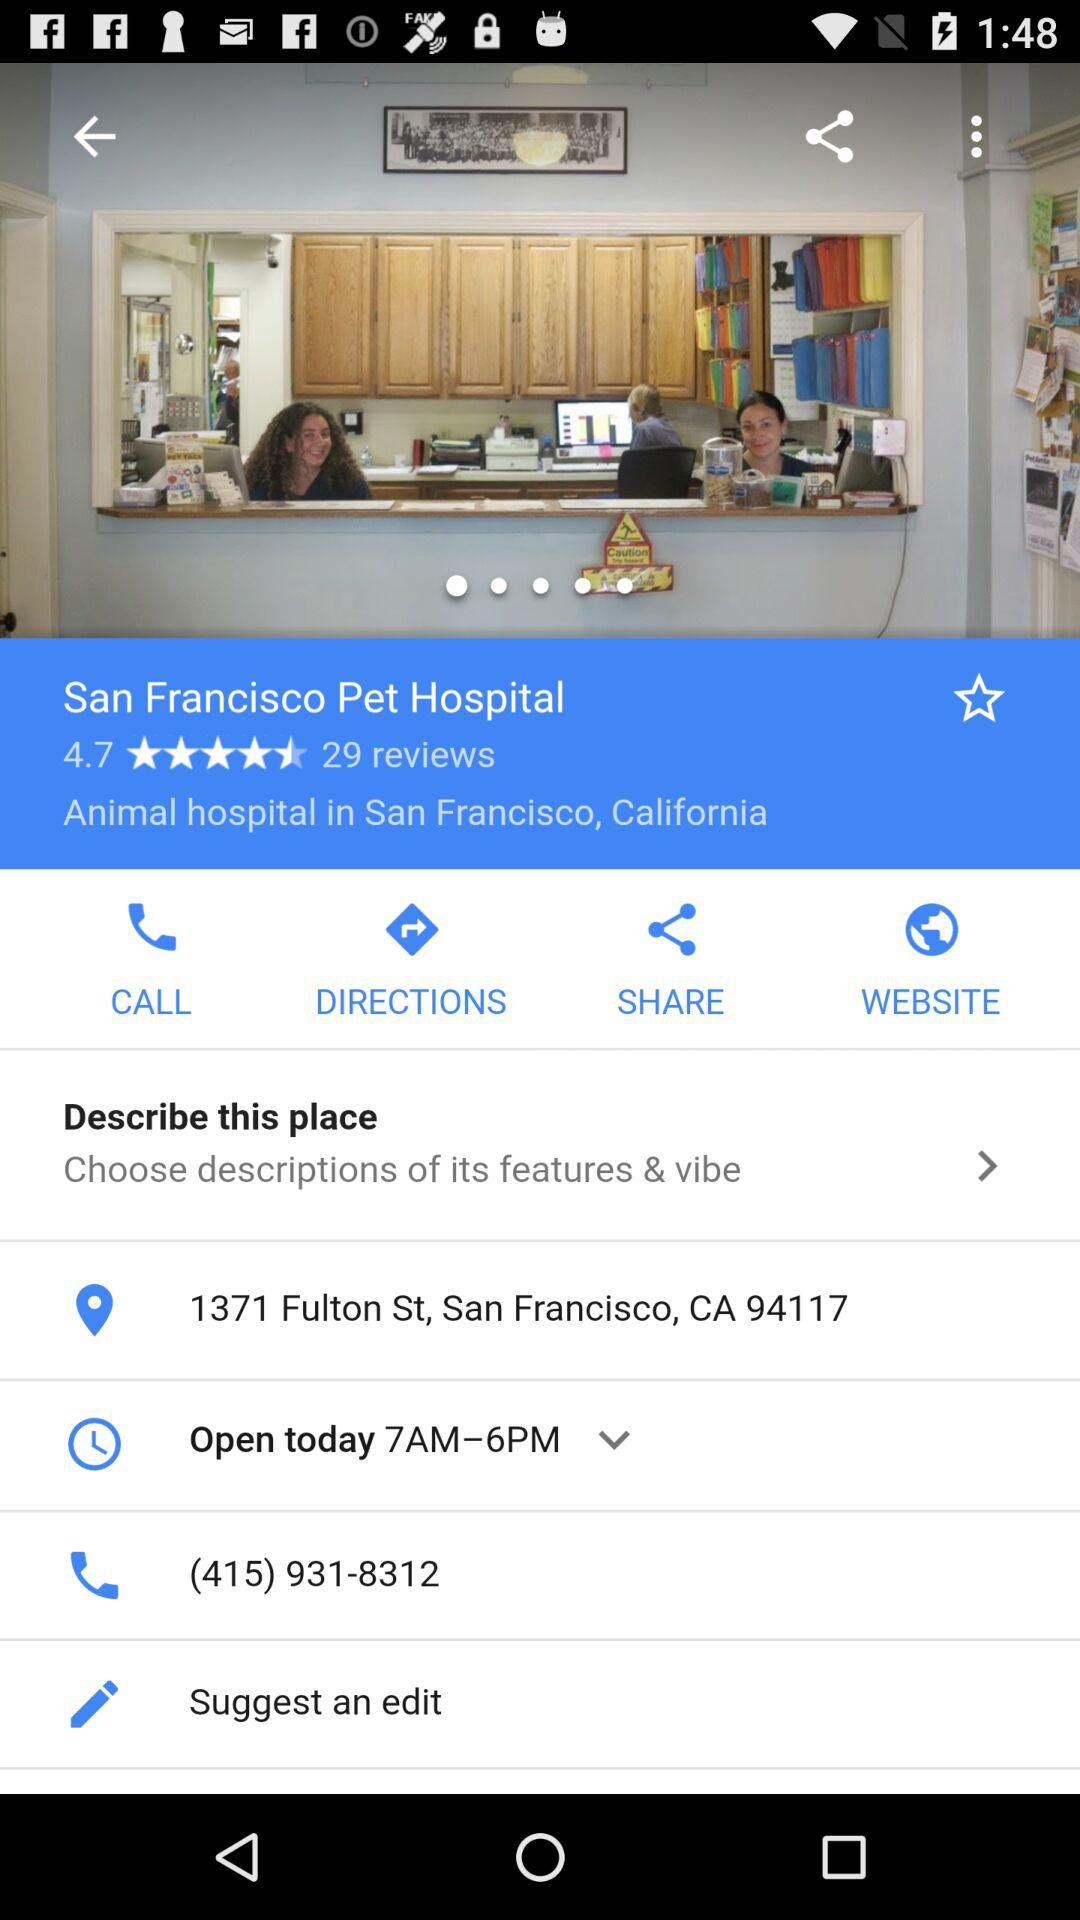What is the hospital name? The hospital name is San Francisco Pet Hospital. 